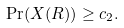<formula> <loc_0><loc_0><loc_500><loc_500>\Pr ( X ( R ) ) \geq c _ { 2 } .</formula> 